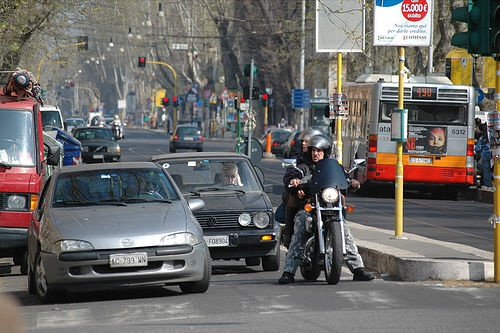Describe the objects in this image and their specific colors. I can see car in gray, black, and darkgray tones, bus in gray, black, darkgray, and red tones, car in gray, black, darkgray, and blue tones, truck in gray, black, brown, and darkgray tones, and motorcycle in gray, black, white, and darkgray tones in this image. 